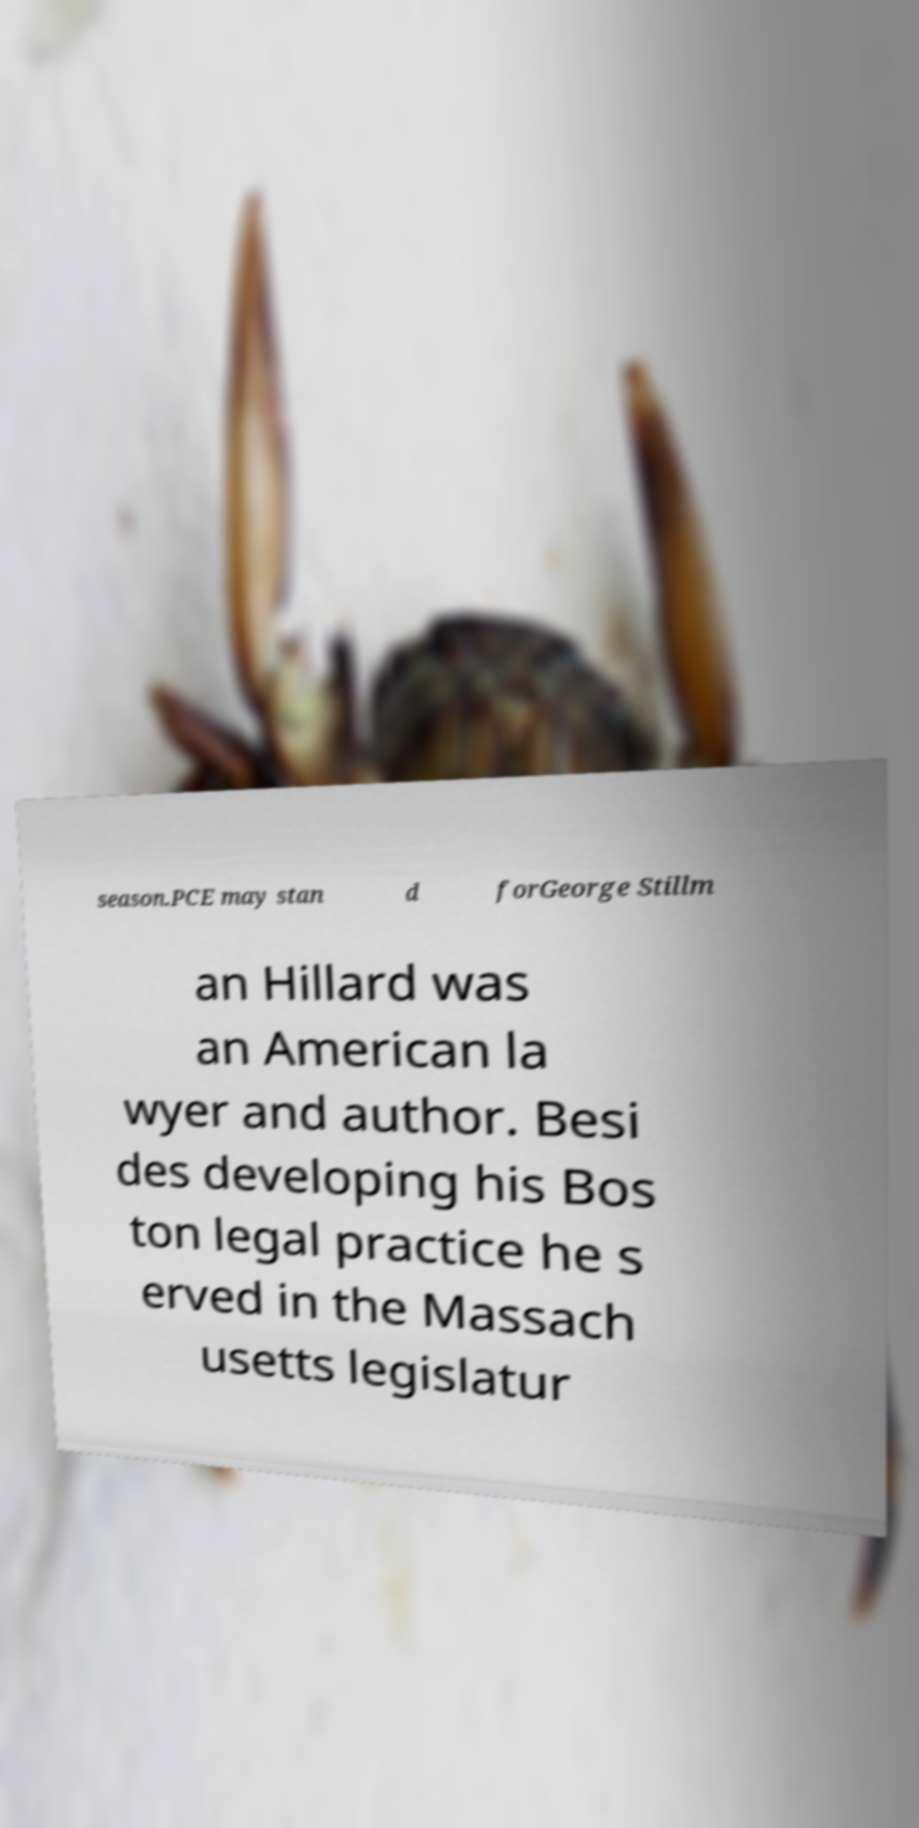Could you extract and type out the text from this image? season.PCE may stan d forGeorge Stillm an Hillard was an American la wyer and author. Besi des developing his Bos ton legal practice he s erved in the Massach usetts legislatur 